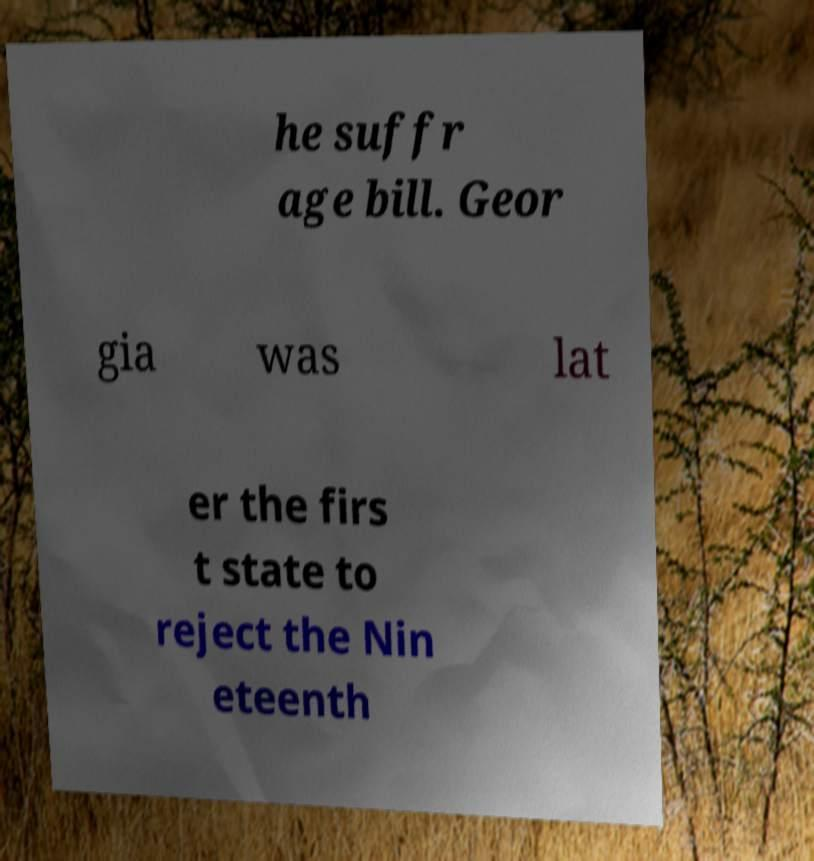Can you read and provide the text displayed in the image?This photo seems to have some interesting text. Can you extract and type it out for me? he suffr age bill. Geor gia was lat er the firs t state to reject the Nin eteenth 